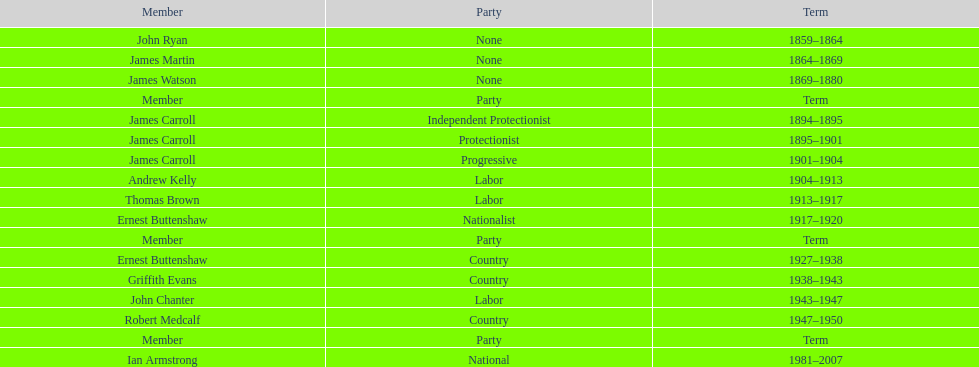Would you be able to parse every entry in this table? {'header': ['Member', 'Party', 'Term'], 'rows': [['John Ryan', 'None', '1859–1864'], ['James Martin', 'None', '1864–1869'], ['James Watson', 'None', '1869–1880'], ['Member', 'Party', 'Term'], ['James Carroll', 'Independent Protectionist', '1894–1895'], ['James Carroll', 'Protectionist', '1895–1901'], ['James Carroll', 'Progressive', '1901–1904'], ['Andrew Kelly', 'Labor', '1904–1913'], ['Thomas Brown', 'Labor', '1913–1917'], ['Ernest Buttenshaw', 'Nationalist', '1917–1920'], ['Member', 'Party', 'Term'], ['Ernest Buttenshaw', 'Country', '1927–1938'], ['Griffith Evans', 'Country', '1938–1943'], ['John Chanter', 'Labor', '1943–1947'], ['Robert Medcalf', 'Country', '1947–1950'], ['Member', 'Party', 'Term'], ['Ian Armstrong', 'National', '1981–2007']]} Who had the most extended tenure among the members of the third iteration of the lachlan? Ernest Buttenshaw. 